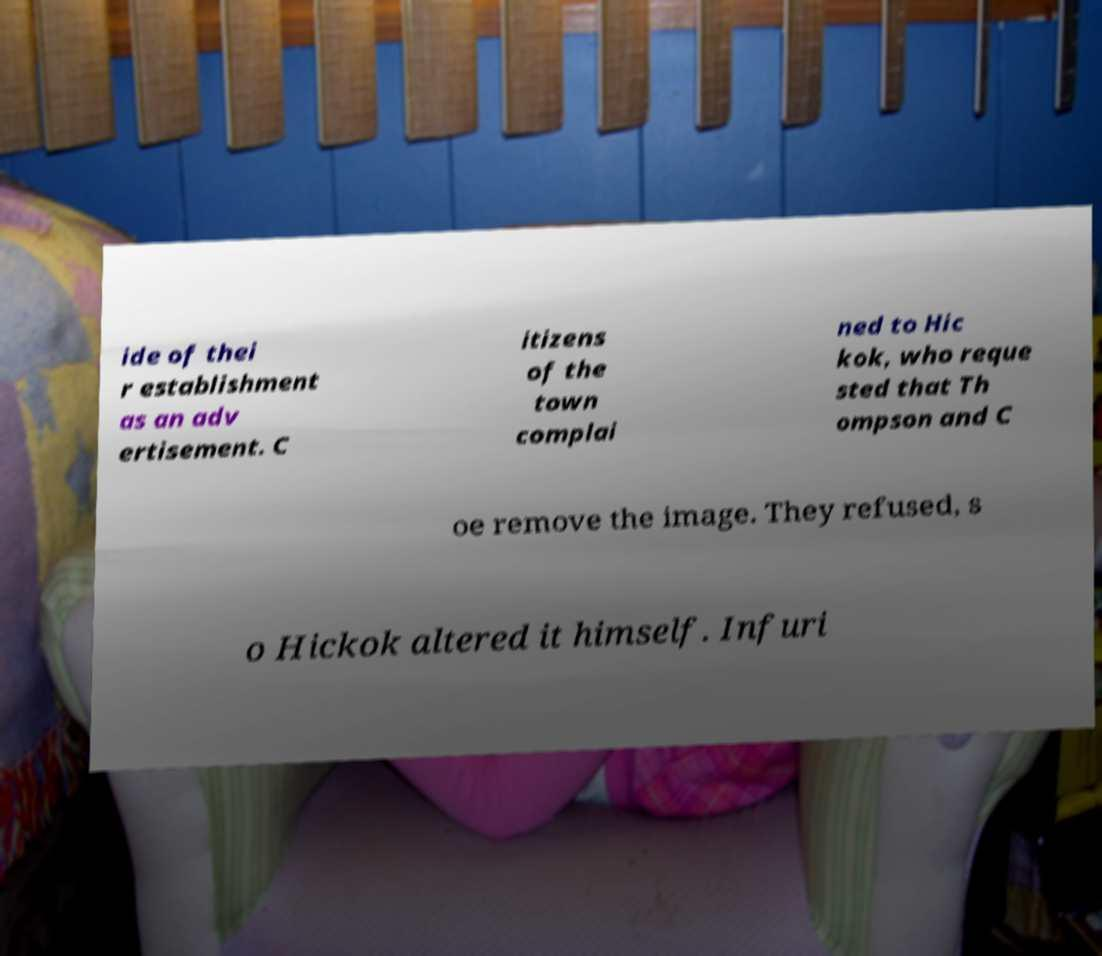What messages or text are displayed in this image? I need them in a readable, typed format. ide of thei r establishment as an adv ertisement. C itizens of the town complai ned to Hic kok, who reque sted that Th ompson and C oe remove the image. They refused, s o Hickok altered it himself. Infuri 